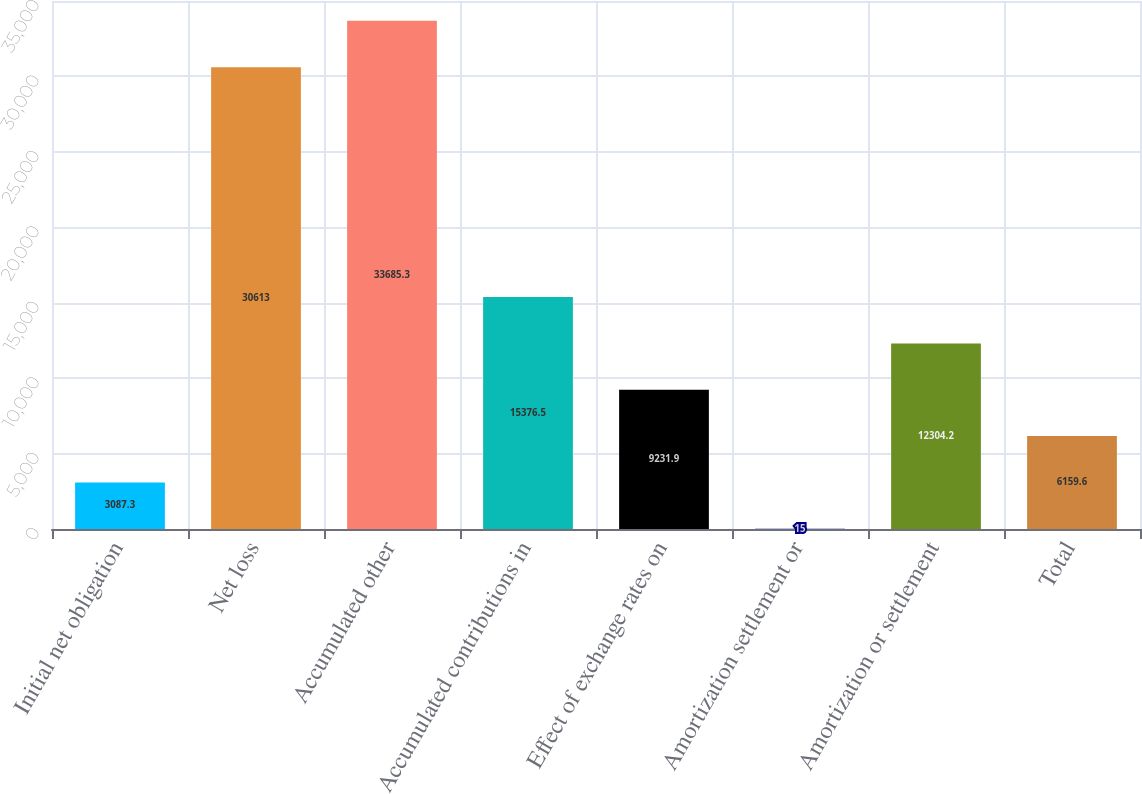Convert chart. <chart><loc_0><loc_0><loc_500><loc_500><bar_chart><fcel>Initial net obligation<fcel>Net loss<fcel>Accumulated other<fcel>Accumulated contributions in<fcel>Effect of exchange rates on<fcel>Amortization settlement or<fcel>Amortization or settlement<fcel>Total<nl><fcel>3087.3<fcel>30613<fcel>33685.3<fcel>15376.5<fcel>9231.9<fcel>15<fcel>12304.2<fcel>6159.6<nl></chart> 